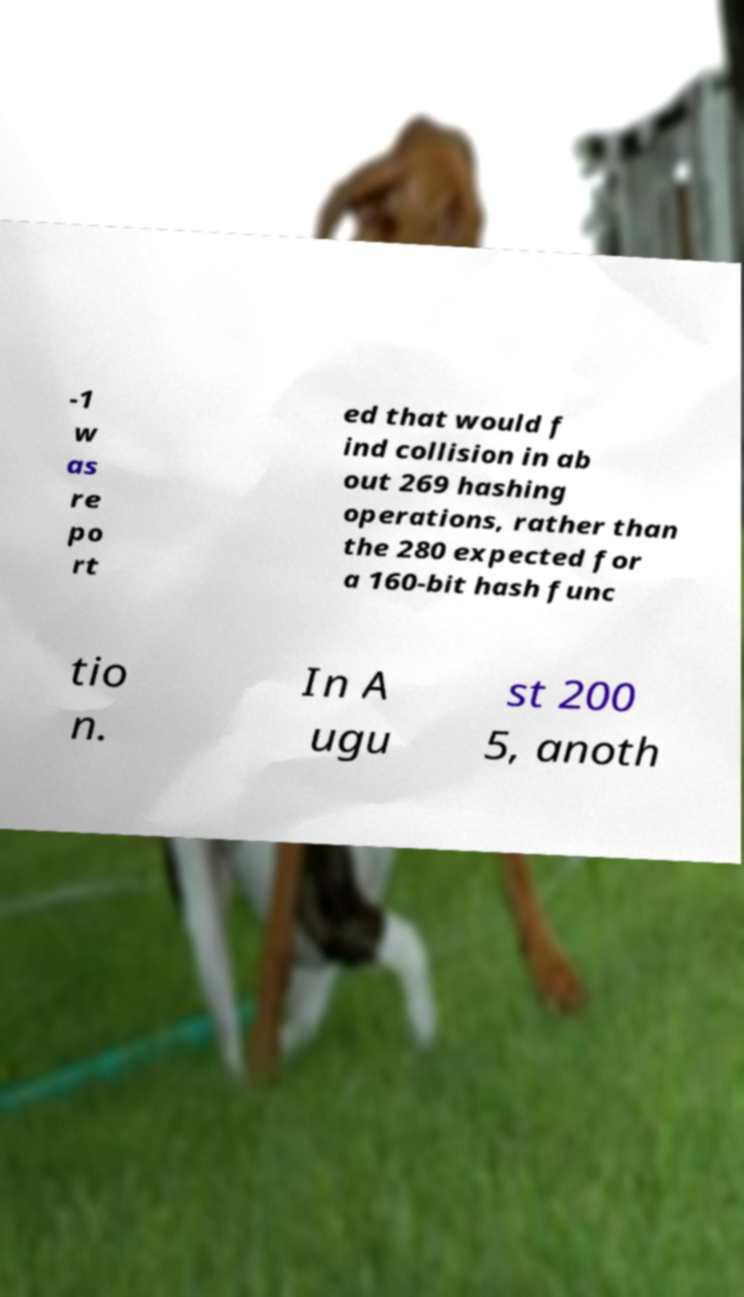For documentation purposes, I need the text within this image transcribed. Could you provide that? -1 w as re po rt ed that would f ind collision in ab out 269 hashing operations, rather than the 280 expected for a 160-bit hash func tio n. In A ugu st 200 5, anoth 